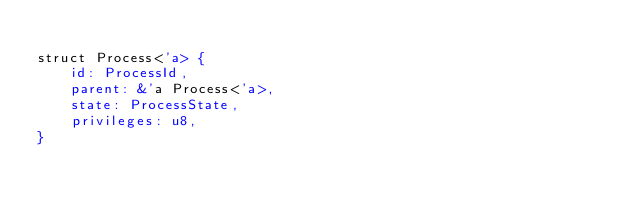Convert code to text. <code><loc_0><loc_0><loc_500><loc_500><_Rust_>
struct Process<'a> {
    id: ProcessId,
    parent: &'a Process<'a>,
    state: ProcessState,
    privileges: u8,
}
</code> 